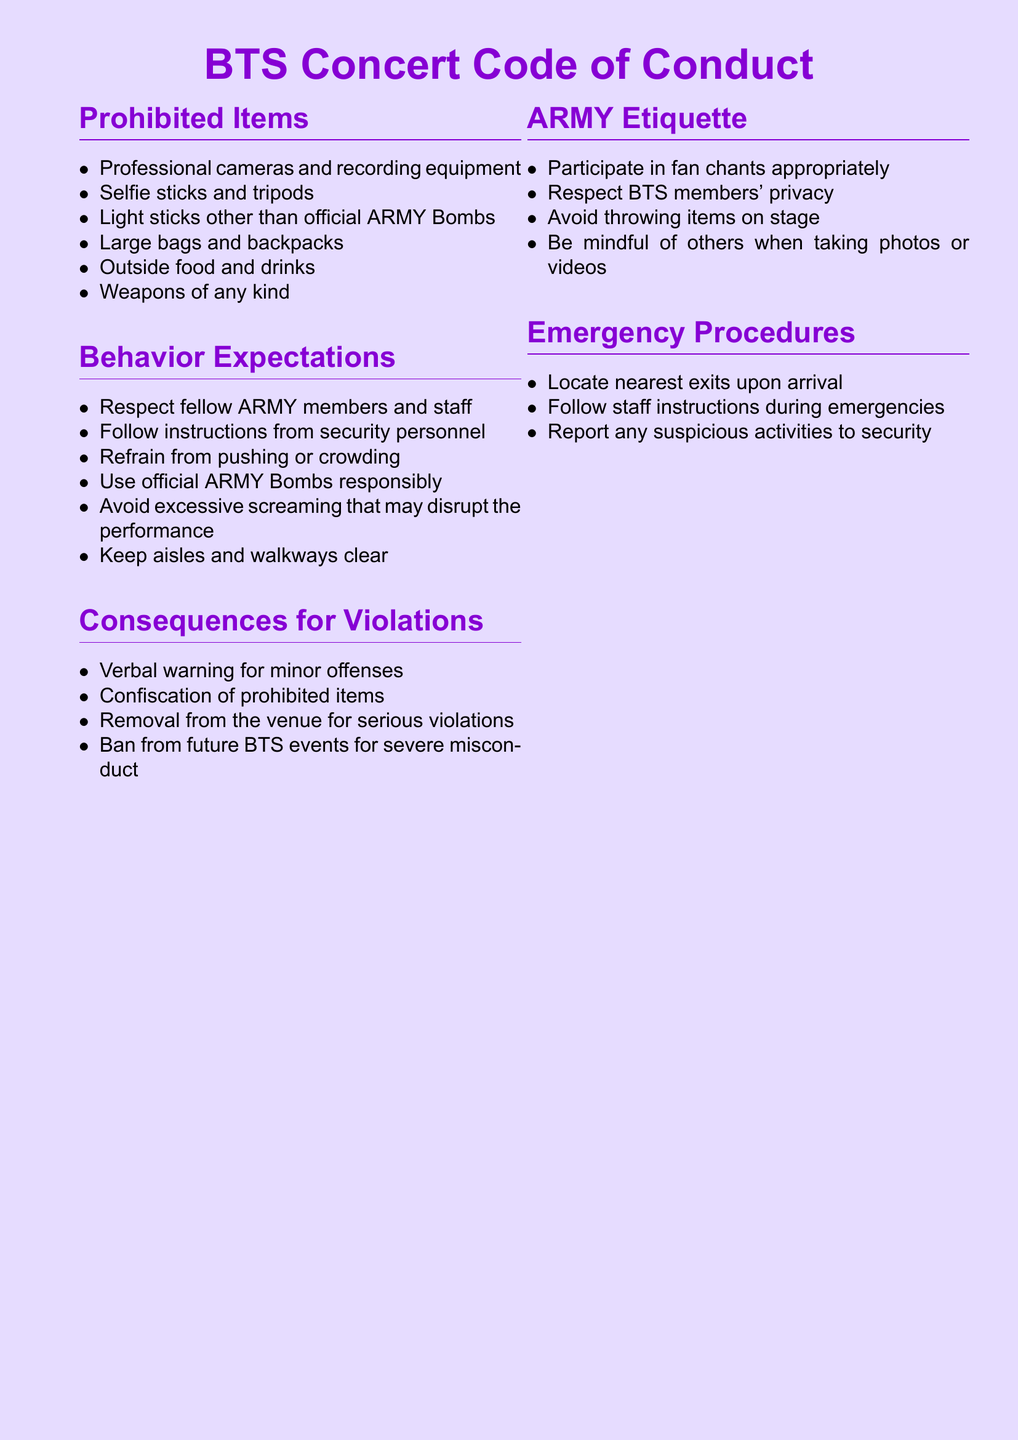What items are prohibited at the concert? The prohibited items are listed under "Prohibited Items" and include specific categories such as cameras, large bags, and weapons.
Answer: Professional cameras, large bags, weapons What behavior is expected from attendees? The expected behaviors are detailed under "Behavior Expectations" and emphasize respect and responsibility.
Answer: Respect fellow ARMY members What could happen if someone violates the code of conduct? The consequences for violations are outlined and range from warnings to removal from the venue.
Answer: Verbal warning Are official ARMY Bombs allowed? The document indicates the use of official ARMY Bombs under specific guidelines in the behavior expectations section.
Answer: Yes What is one of the consequences for serious violations? The consequences section specifies what happens for serious offenses, including removal from the venue.
Answer: Removal from the venue How should attendees respond in emergencies? The "Emergency Procedures" section provides guidance on necessary actions during emergencies.
Answer: Follow staff instructions 